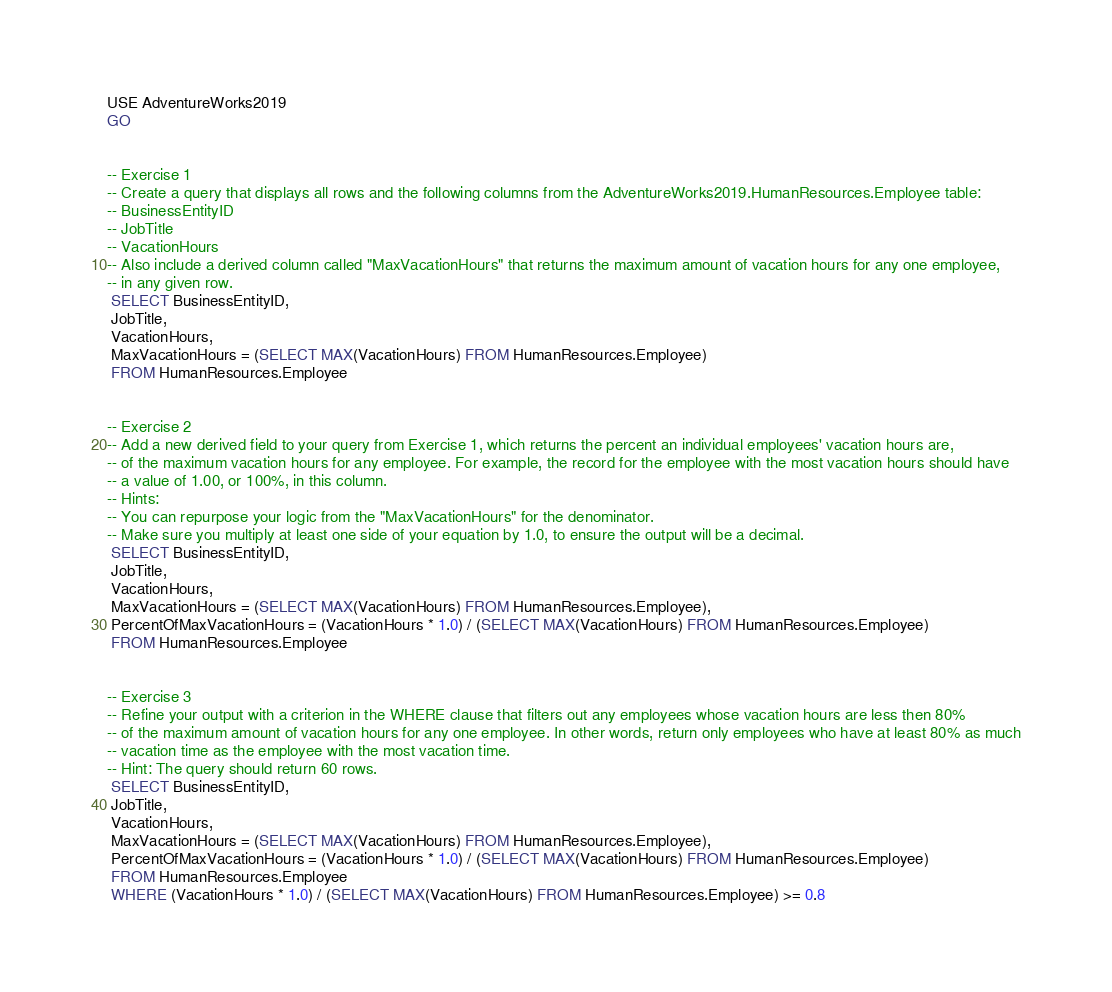<code> <loc_0><loc_0><loc_500><loc_500><_SQL_>USE AdventureWorks2019
GO


-- Exercise 1
-- Create a query that displays all rows and the following columns from the AdventureWorks2019.HumanResources.Employee table:
-- BusinessEntityID
-- JobTitle
-- VacationHours
-- Also include a derived column called "MaxVacationHours" that returns the maximum amount of vacation hours for any one employee,
-- in any given row.
 SELECT BusinessEntityID,
 JobTitle,
 VacationHours,
 MaxVacationHours = (SELECT MAX(VacationHours) FROM HumanResources.Employee)
 FROM HumanResources.Employee


-- Exercise 2
-- Add a new derived field to your query from Exercise 1, which returns the percent an individual employees' vacation hours are,
-- of the maximum vacation hours for any employee. For example, the record for the employee with the most vacation hours should have
-- a value of 1.00, or 100%, in this column.
-- Hints:
-- You can repurpose your logic from the "MaxVacationHours" for the denominator.
-- Make sure you multiply at least one side of your equation by 1.0, to ensure the output will be a decimal.
 SELECT BusinessEntityID,
 JobTitle,
 VacationHours,
 MaxVacationHours = (SELECT MAX(VacationHours) FROM HumanResources.Employee),
 PercentOfMaxVacationHours = (VacationHours * 1.0) / (SELECT MAX(VacationHours) FROM HumanResources.Employee)
 FROM HumanResources.Employee


-- Exercise 3
-- Refine your output with a criterion in the WHERE clause that filters out any employees whose vacation hours are less then 80%
-- of the maximum amount of vacation hours for any one employee. In other words, return only employees who have at least 80% as much
-- vacation time as the employee with the most vacation time.
-- Hint: The query should return 60 rows.
 SELECT BusinessEntityID,
 JobTitle,
 VacationHours,
 MaxVacationHours = (SELECT MAX(VacationHours) FROM HumanResources.Employee),
 PercentOfMaxVacationHours = (VacationHours * 1.0) / (SELECT MAX(VacationHours) FROM HumanResources.Employee)
 FROM HumanResources.Employee
 WHERE (VacationHours * 1.0) / (SELECT MAX(VacationHours) FROM HumanResources.Employee) >= 0.8

</code> 